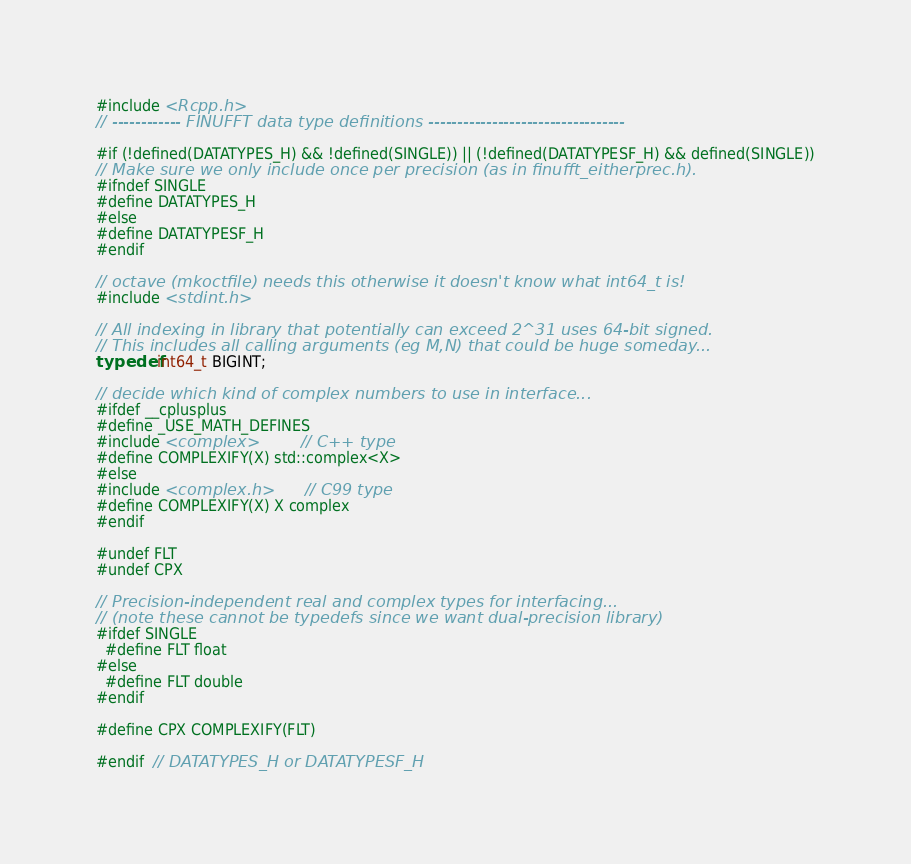<code> <loc_0><loc_0><loc_500><loc_500><_C_>#include <Rcpp.h>
// ------------ FINUFFT data type definitions ----------------------------------

#if (!defined(DATATYPES_H) && !defined(SINGLE)) || (!defined(DATATYPESF_H) && defined(SINGLE))
// Make sure we only include once per precision (as in finufft_eitherprec.h).
#ifndef SINGLE
#define DATATYPES_H
#else
#define DATATYPESF_H
#endif

// octave (mkoctfile) needs this otherwise it doesn't know what int64_t is!
#include <stdint.h>

// All indexing in library that potentially can exceed 2^31 uses 64-bit signed.
// This includes all calling arguments (eg M,N) that could be huge someday...
typedef int64_t BIGINT;

// decide which kind of complex numbers to use in interface...
#ifdef __cplusplus
#define _USE_MATH_DEFINES
#include <complex>          // C++ type
#define COMPLEXIFY(X) std::complex<X>
#else
#include <complex.h>        // C99 type
#define COMPLEXIFY(X) X complex
#endif

#undef FLT
#undef CPX

// Precision-independent real and complex types for interfacing...
// (note these cannot be typedefs since we want dual-precision library)
#ifdef SINGLE
  #define FLT float
#else
  #define FLT double
#endif

#define CPX COMPLEXIFY(FLT)

#endif  // DATATYPES_H or DATATYPESF_H
</code> 